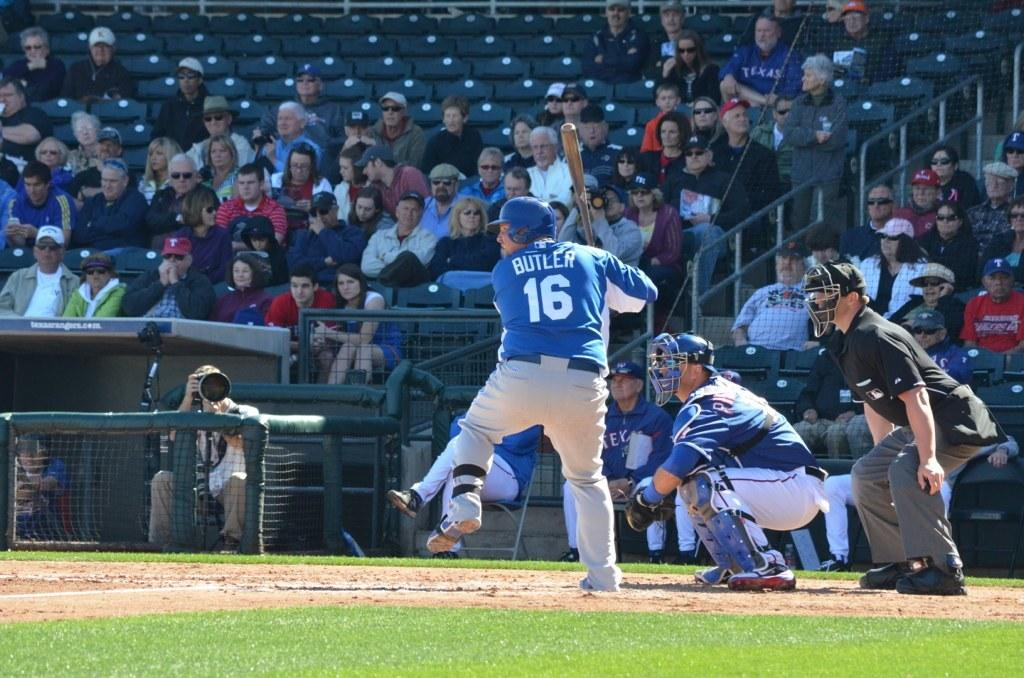<image>
Render a clear and concise summary of the photo. A baseball player named Butler is about to hit the ball. 